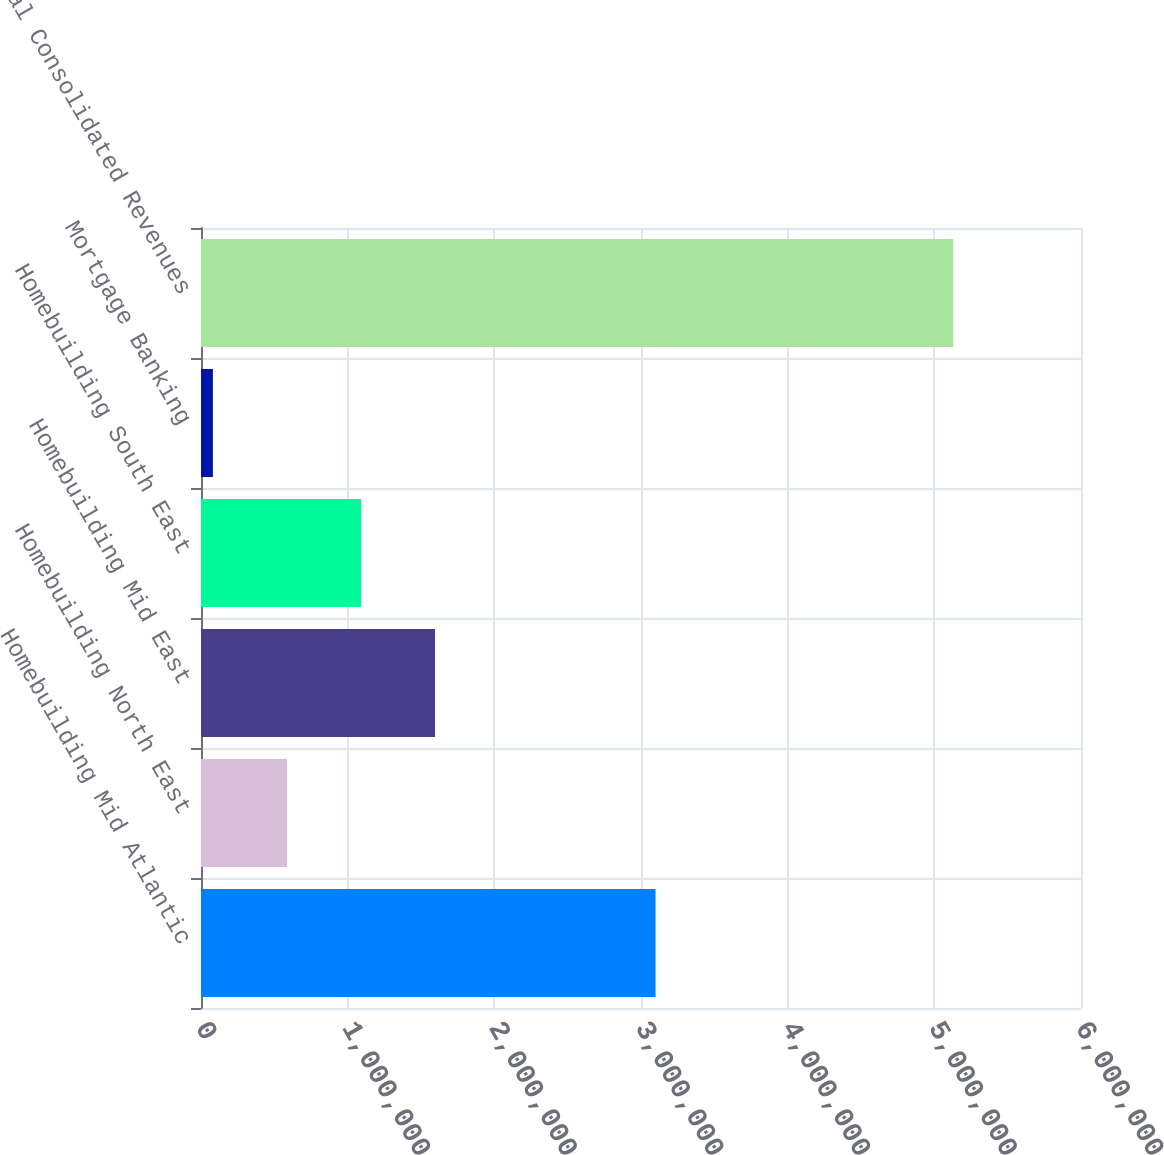<chart> <loc_0><loc_0><loc_500><loc_500><bar_chart><fcel>Homebuilding Mid Atlantic<fcel>Homebuilding North East<fcel>Homebuilding Mid East<fcel>Homebuilding South East<fcel>Mortgage Banking<fcel>Total Consolidated Revenues<nl><fcel>3.09905e+06<fcel>585974<fcel>1.59561e+06<fcel>1.09079e+06<fcel>81155<fcel>5.12934e+06<nl></chart> 